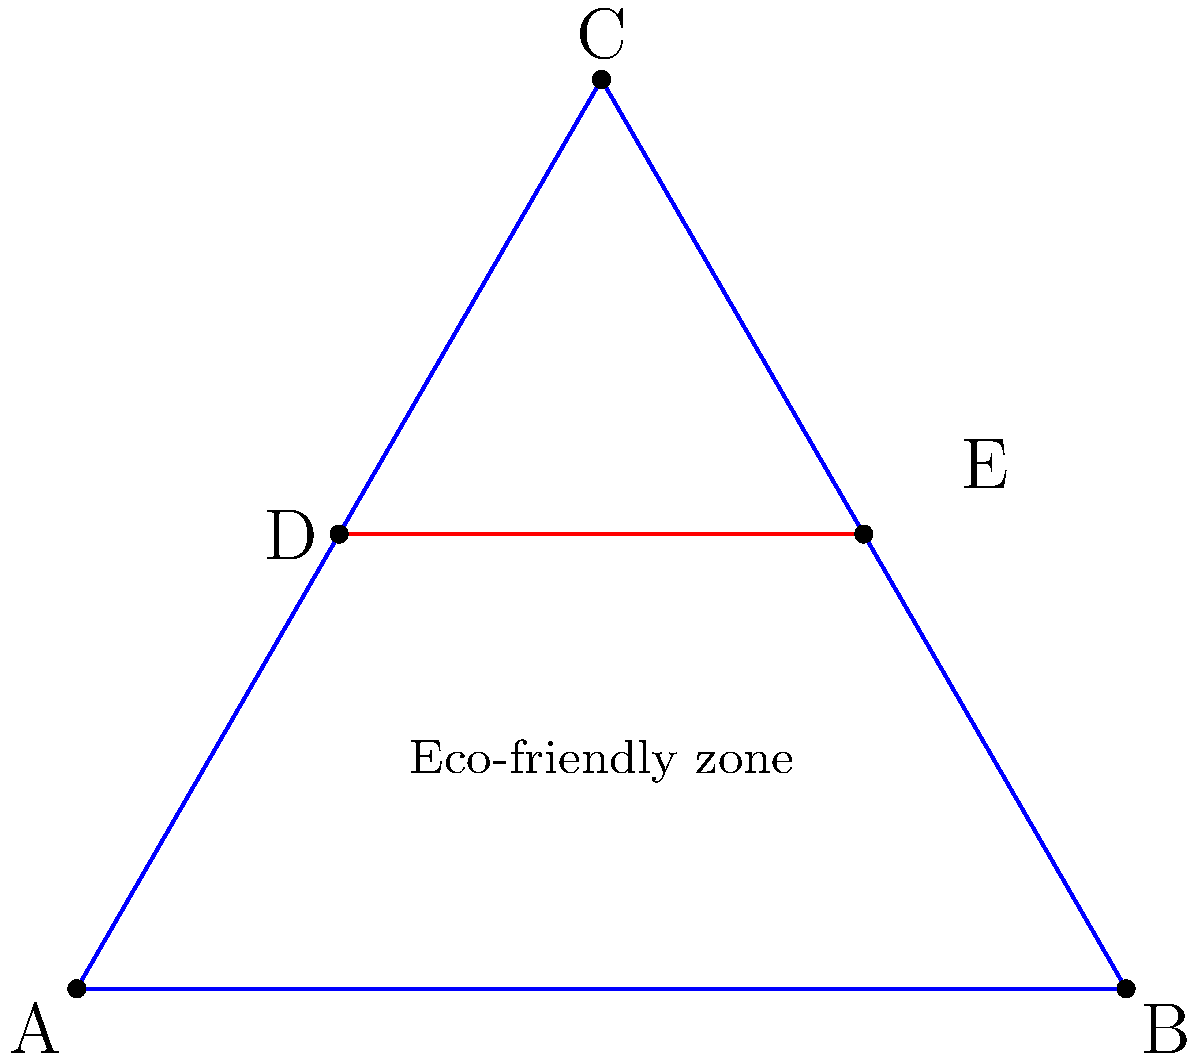In planning an eco-friendly neighborhood in the Grand Est region, you propose a triangular layout as shown. The base of the triangle (AB) is 6 km, and the height (CD) is 2.6 km. A green corridor (DE) is planned parallel to the base, dividing the triangle into two zones. If the eco-friendly zone (ABDE) should occupy 60% of the total area, at what distance from the base should the green corridor be placed? Let's approach this step-by-step:

1) First, we need to calculate the total area of the triangle ABC.
   Area of triangle = $\frac{1}{2} \times$ base $\times$ height
   $A_{ABC} = \frac{1}{2} \times 6 \times 2.6 = 7.8$ km²

2) The eco-friendly zone should occupy 60% of this area.
   $A_{ABDE} = 60\% \times 7.8 = 0.6 \times 7.8 = 4.68$ km²

3) Let's say the distance of DE from AB is $x$ km. Then:
   $A_{ABDE} = \frac{1}{2} \times 6 \times x = 3x$ km²

4) We can now set up an equation:
   $3x = 4.68$

5) Solving for $x$:
   $x = \frac{4.68}{3} = 1.56$ km

Therefore, the green corridor should be placed 1.56 km from the base of the triangle.
Answer: 1.56 km 